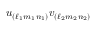<formula> <loc_0><loc_0><loc_500><loc_500>u _ { ( \ell _ { 1 } m _ { 1 } n _ { 1 } ) } v _ { ( \ell _ { 2 } m _ { 2 } n _ { 2 } ) }</formula> 